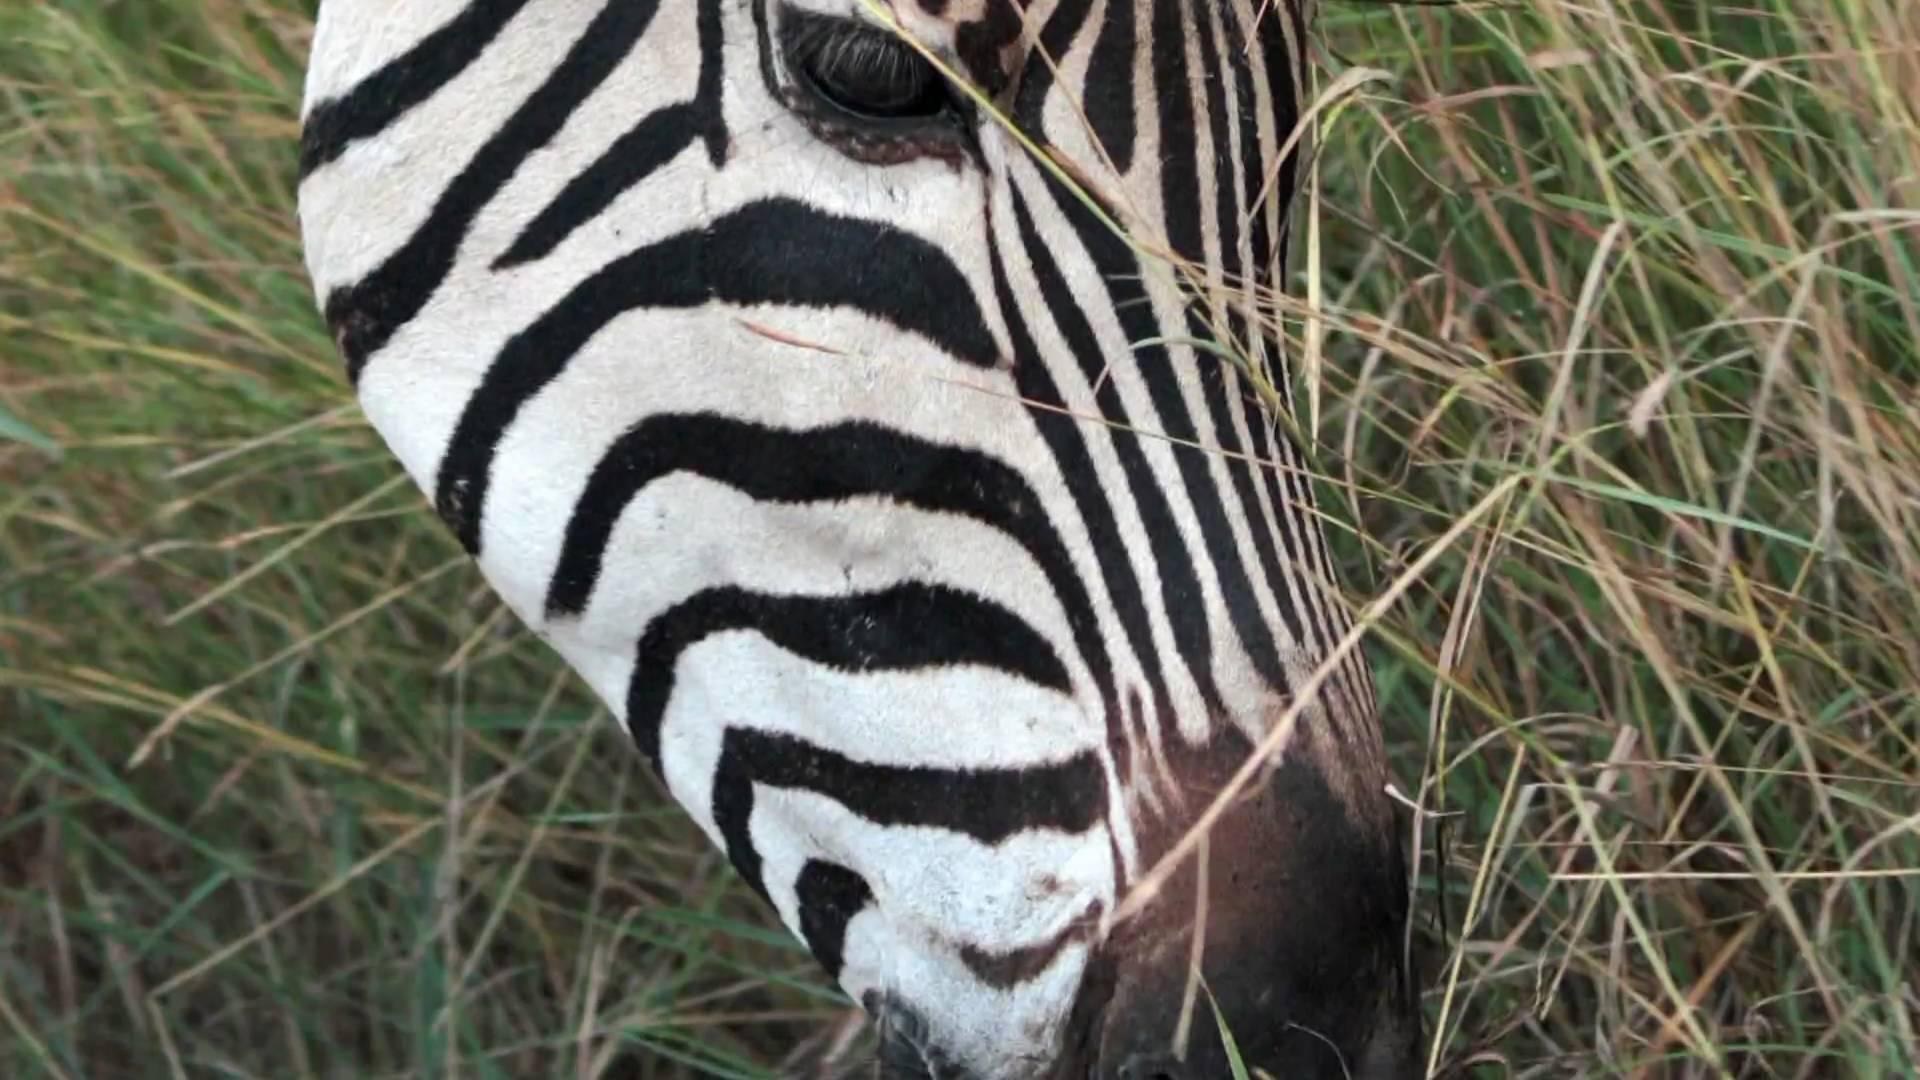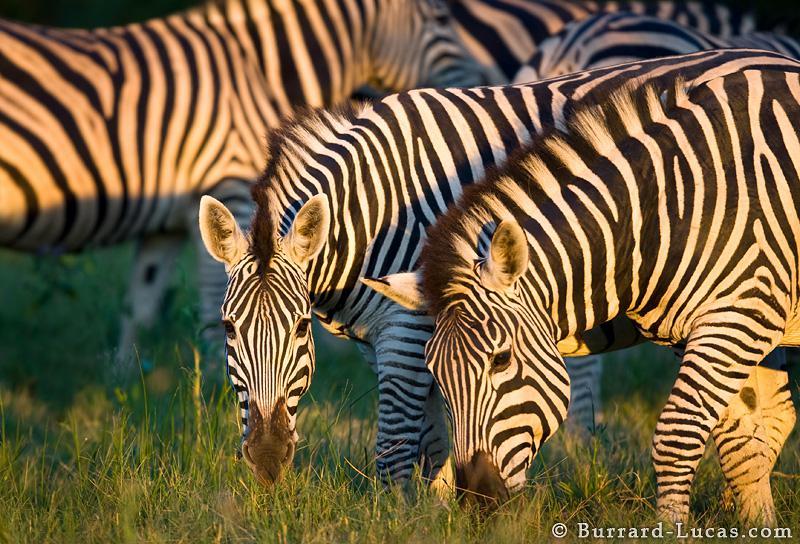The first image is the image on the left, the second image is the image on the right. Assess this claim about the two images: "The left and right image contains the same number of zebras.". Correct or not? Answer yes or no. No. 